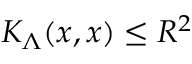Convert formula to latex. <formula><loc_0><loc_0><loc_500><loc_500>K _ { \Lambda } ( x , x ) \leq R ^ { 2 }</formula> 